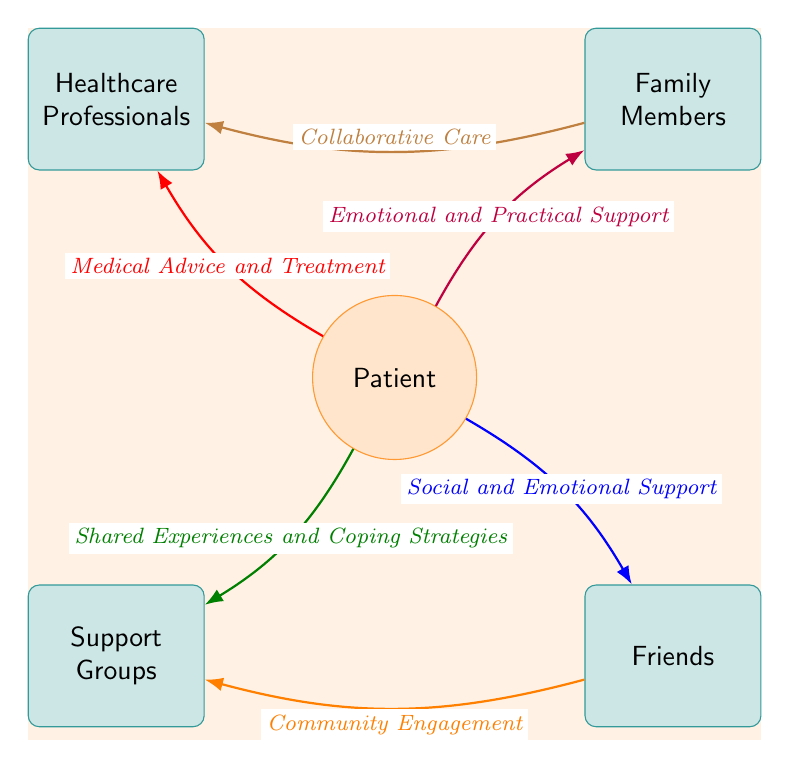What is the relationship between the patient and family members? The diagram shows that the patient receives "Emotional and Practical Support" from family members, indicating a supportive relationship that addresses both emotional needs and practical assistance.
Answer: Emotional and Practical Support How many support sources are connected to the patient? By counting the nodes connected to the patient, we see there are four sources: Family Members, Friends, Healthcare Professionals, and Support Groups.
Answer: Four What type of support do friends provide to the patient? According to the diagram, friends provide "Social and Emotional Support" to the patient, highlighting the importance of friendship in coping with challenges.
Answer: Social and Emotional Support What connection exists between family members and healthcare professionals? The diagram indicates a connection where family members contribute to "Collaborative Care" with healthcare professionals, showing that they work together for the patient's wellbeing.
Answer: Collaborative Care Which group offers shared experiences and coping strategies? The diagram specifies that Support Groups are the ones providing "Shared Experiences and Coping Strategies," emphasizing their role in helping patients through similar challenges.
Answer: Shared Experiences and Coping Strategies What type of relationship exists between friends and support groups? Friends contribute to "Community Engagement," which connects to support groups, suggesting an interaction that encourages shared experiences and involvement in community support.
Answer: Community Engagement What color represents the connection between the patient and healthcare professionals? The connection between the patient and healthcare professionals is indicated in red, which helps visually distinguish the type of support provided.
Answer: Red How is the patient connected to support groups? The diagram shows a direct link from the patient to support groups for "Shared Experiences and Coping Strategies," illustrating the support network's importance.
Answer: Shared Experiences and Coping Strategies What is the main role of healthcare professionals in the patient’s support network? Healthcare professionals primarily provide "Medical Advice and Treatment," reflecting their critical role in managing the patient's health.
Answer: Medical Advice and Treatment 